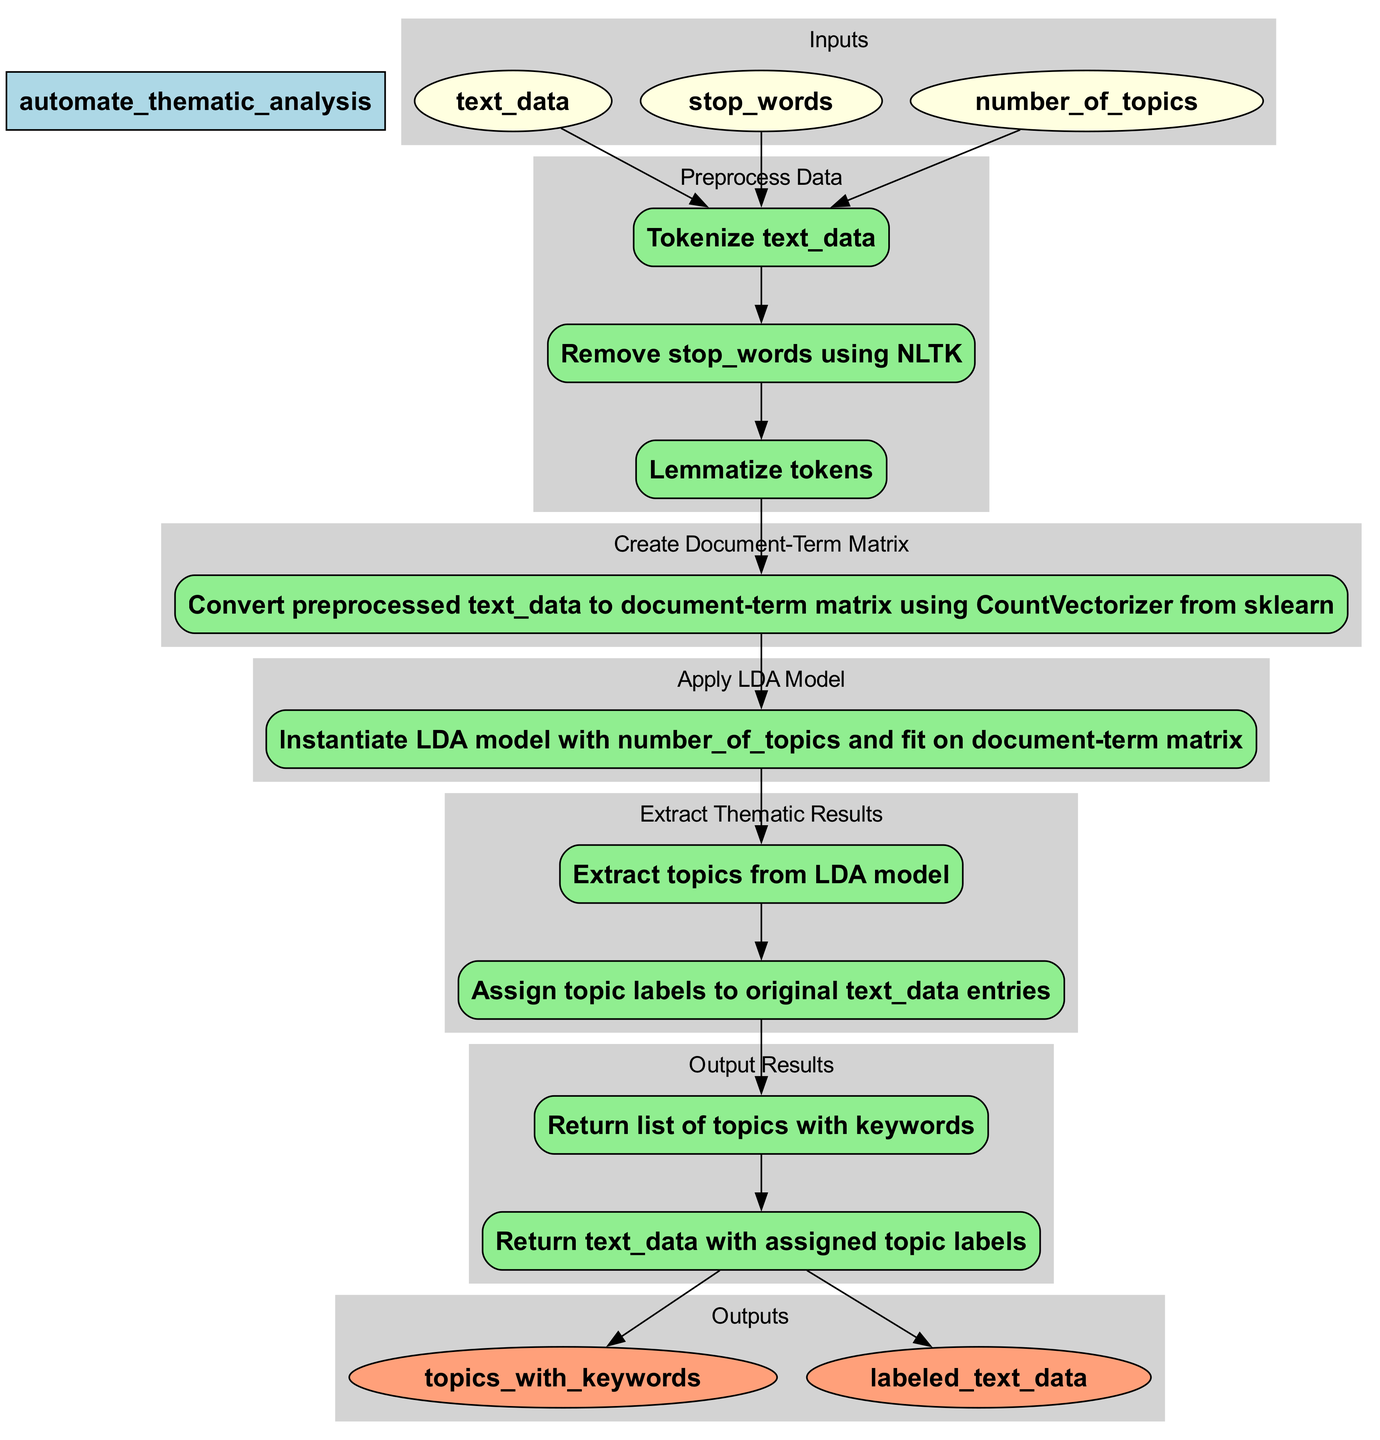What is the name of the function in this diagram? The diagram represents a function called "automate_thematic_analysis", which is noted at the top of the flowchart.
Answer: automate thematic analysis How many inputs does the function have? The function has three inputs: "text_data", "stop_words", and "number_of_topics", which can be counted from the input nodes in the diagram.
Answer: 3 What is the first step in the process? The first step listed in the flowchart is "Preprocess Data", which is the initial step connecting the inputs to the processing pathway.
Answer: Preprocess Data How many actions are there for the "Extract Thematic Results" step? The "Extract Thematic Results" step contains two actions: "Extract topics from LDA model" and "Assign topic labels to original text_data entries", which can be counted in that section of the flowchart.
Answer: 2 What outputs does the function provide? The function provides two outputs: "topics_with_keywords" and "labeled_text_data", as represented in the output nodes of the flowchart.
Answer: topics with keywords, labeled text data Which model is applied in the third step of the process? The third step involves applying the LDA model, which is explicitly stated as part of the actions in that segment of the flowchart.
Answer: LDA model What connects the "Create Document-Term Matrix" step to the "Apply LDA Model" step? An edge connects the last action of the "Create Document-Term Matrix" step to the first action of the "Apply LDA Model" step, indicating the flow of data from one step to the next in the process.
Answer: An edge How is "text_data" utilized in the function? "text_data" is processed through several steps beginning with preprocessing, then constructing a document-term matrix, followed by topic modeling, and ultimately producing labeled text data and topics with keywords.
Answer: Processed in multiple steps 